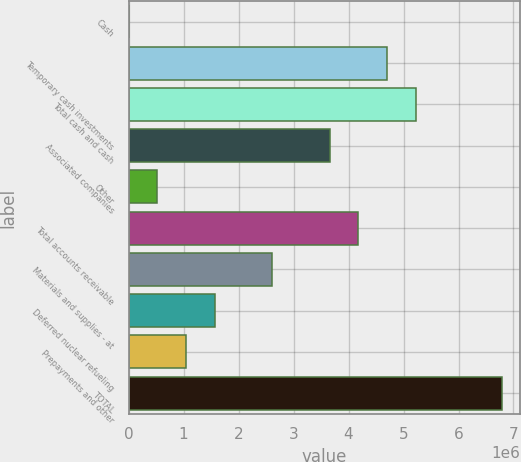Convert chart to OTSL. <chart><loc_0><loc_0><loc_500><loc_500><bar_chart><fcel>Cash<fcel>Temporary cash investments<fcel>Total cash and cash<fcel>Associated companies<fcel>Other<fcel>Total accounts receivable<fcel>Materials and supplies - at<fcel>Deferred nuclear refueling<fcel>Prepayments and other<fcel>TOTAL<nl><fcel>786<fcel>4.69833e+06<fcel>5.22028e+06<fcel>3.65443e+06<fcel>522735<fcel>4.17638e+06<fcel>2.61053e+06<fcel>1.56663e+06<fcel>1.04468e+06<fcel>6.78612e+06<nl></chart> 